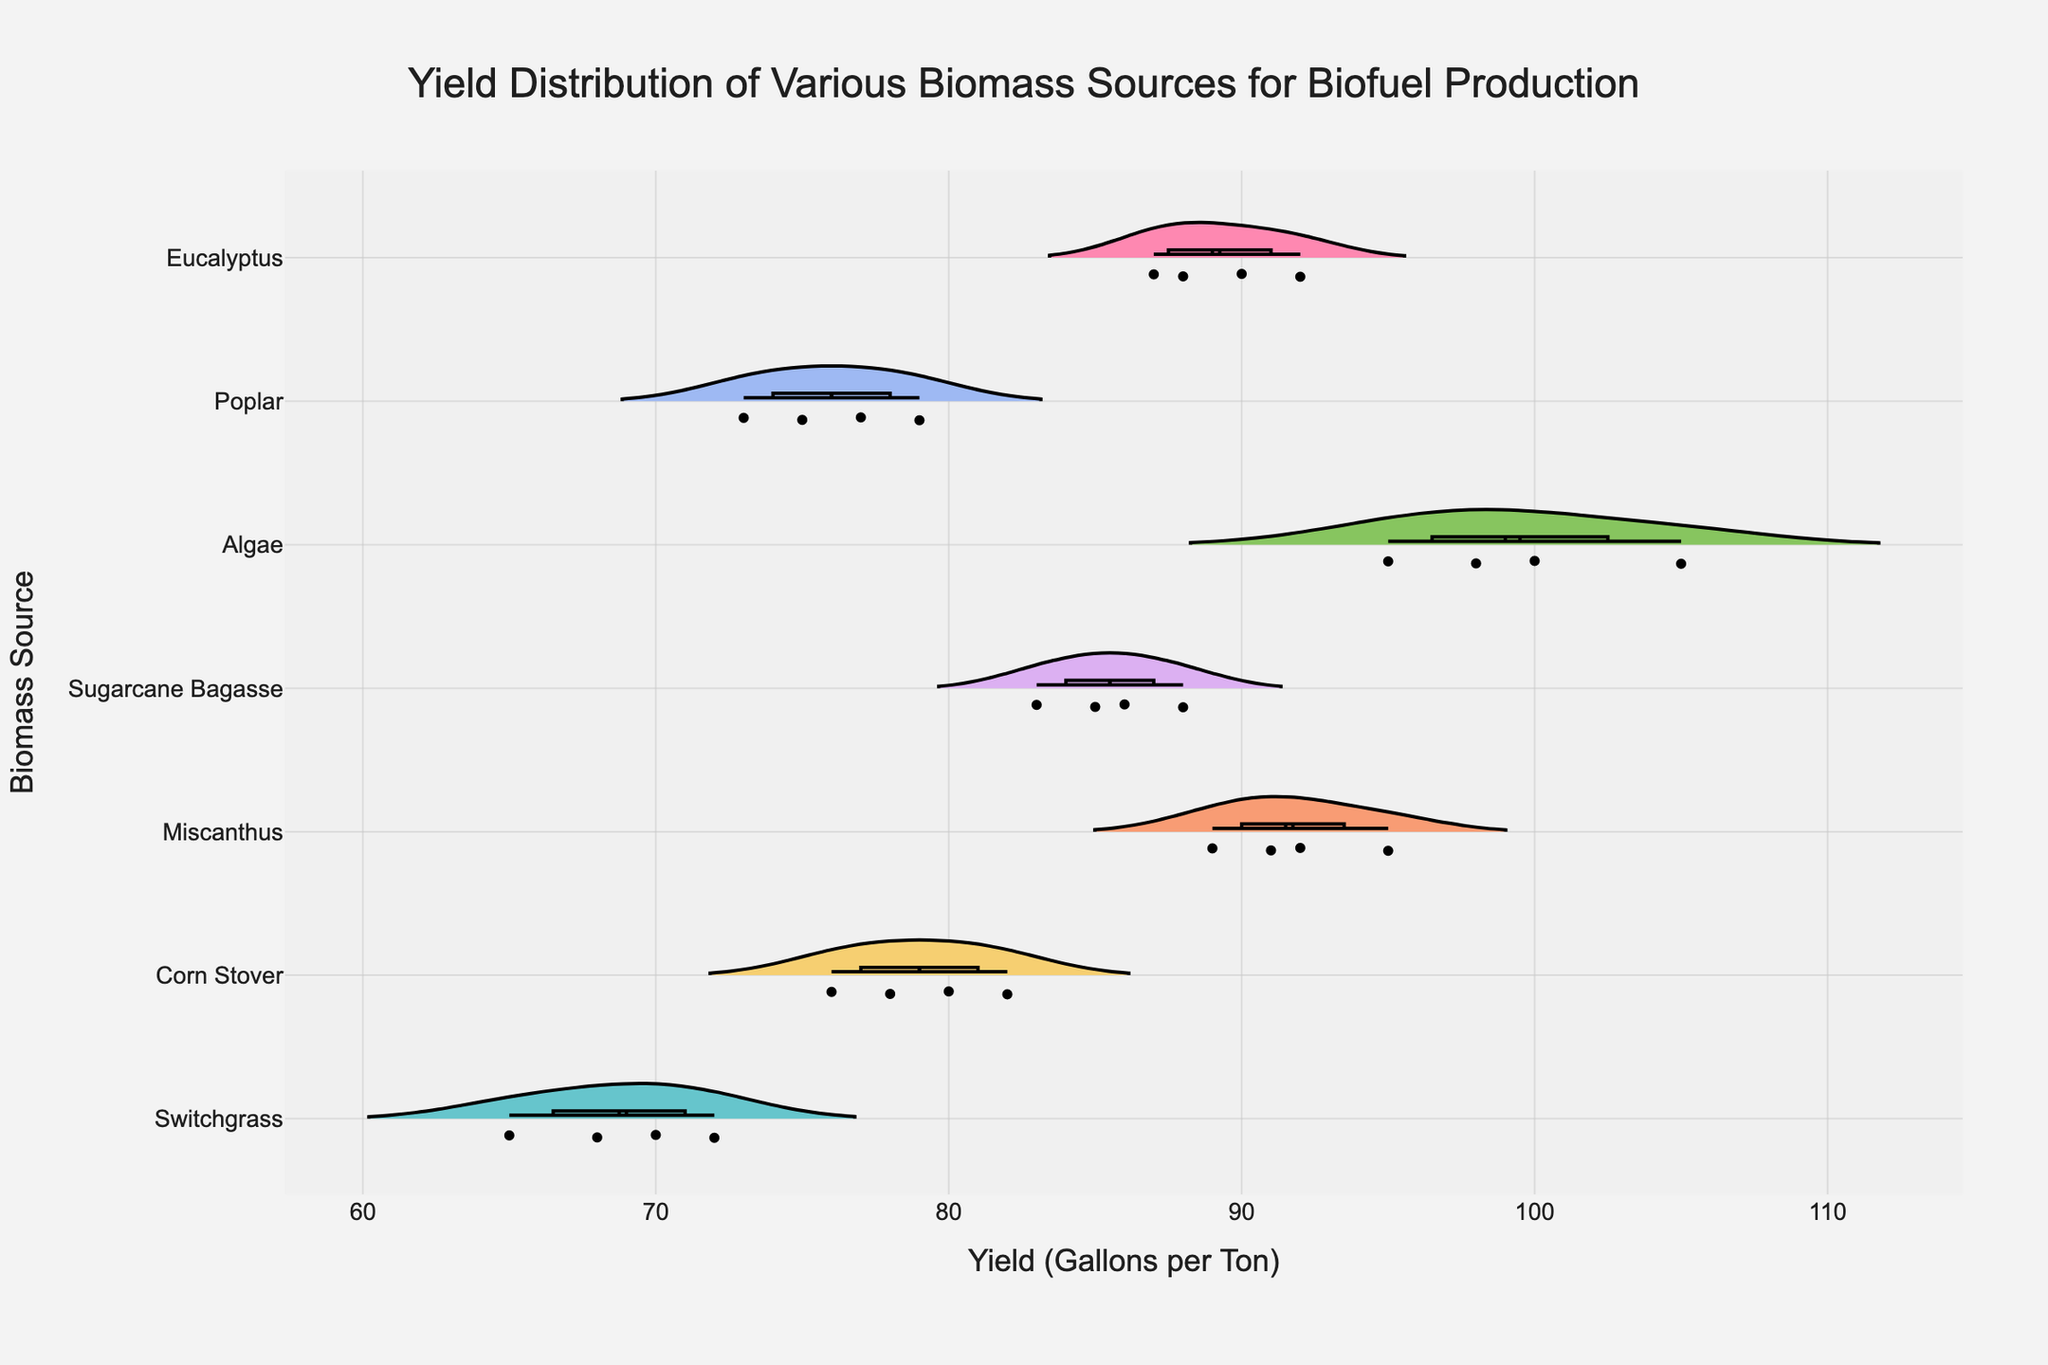What is the title of the figure? The title is typically located at the top of the figure and explicitly states what the figure is about.
Answer: Yield Distribution of Various Biomass Sources for Biofuel Production Which biomass source has the highest median yield? Find the median line within each violin plot and identify the highest one among all groups.
Answer: Algae How many data points are there for Sugarcane Bagasse? Count the individual points represented within the violin plot for Sugarcane Bagasse.
Answer: 4 Which biomass source shows the widest distribution in yield? Observe the length of the violin plots along the x-axis; the widest one has the most significant spread in yield values.
Answer: Algae What is the range of yields for Corn Stover? Identify the minimum and maximum points within the Corn Stover violin plot and calculate their difference.
Answer: 76 - 82 Which biomass sources have a mean yield greater than 90 gallons per ton? Look at the mean lines within the violin plots and note which biomass sources have their mean lines positioned above the 90 value on the x-axis.
Answer: Algae, Miscanthus, Eucalyptus Between Switchgrass and Poplar, which biomass source has a higher average yield? Compare the mean lines in the violin plots for Switchgrass and Poplar; identify which one is higher.
Answer: Switchgrass Are all the yield values for eucalyptus above 85 gallons per ton? Check the entire range of the Eucalyptus violin plot and confirm if all points are greater than 85.
Answer: Yes Which biomass source has the smallest interquartile range (IQR) in yield? Identify the shortest distance between the box's upper and lower bounds within the violin plots.
Answer: Corn Stover What are the minimum and maximum yields for Miscanthus? Identify the lowest and highest points within the Miscanthus violin plot.
Answer: 89, 95 